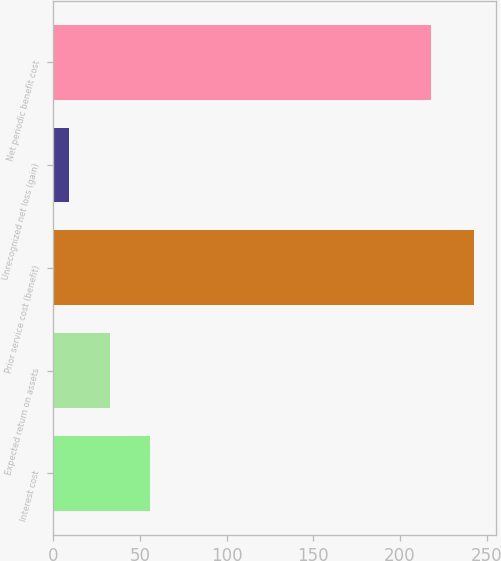Convert chart to OTSL. <chart><loc_0><loc_0><loc_500><loc_500><bar_chart><fcel>Interest cost<fcel>Expected return on assets<fcel>Prior service cost (benefit)<fcel>Unrecognized net loss (gain)<fcel>Net periodic benefit cost<nl><fcel>55.8<fcel>32.4<fcel>243<fcel>9<fcel>218<nl></chart> 